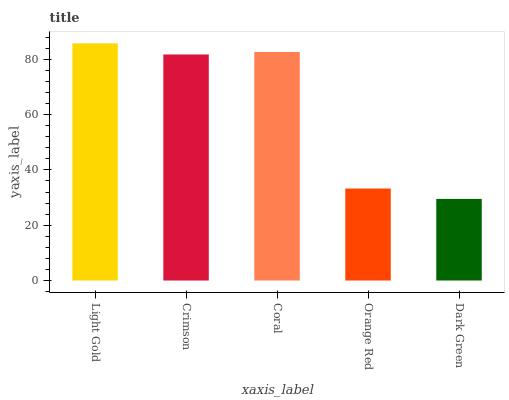Is Crimson the minimum?
Answer yes or no. No. Is Crimson the maximum?
Answer yes or no. No. Is Light Gold greater than Crimson?
Answer yes or no. Yes. Is Crimson less than Light Gold?
Answer yes or no. Yes. Is Crimson greater than Light Gold?
Answer yes or no. No. Is Light Gold less than Crimson?
Answer yes or no. No. Is Crimson the high median?
Answer yes or no. Yes. Is Crimson the low median?
Answer yes or no. Yes. Is Dark Green the high median?
Answer yes or no. No. Is Light Gold the low median?
Answer yes or no. No. 